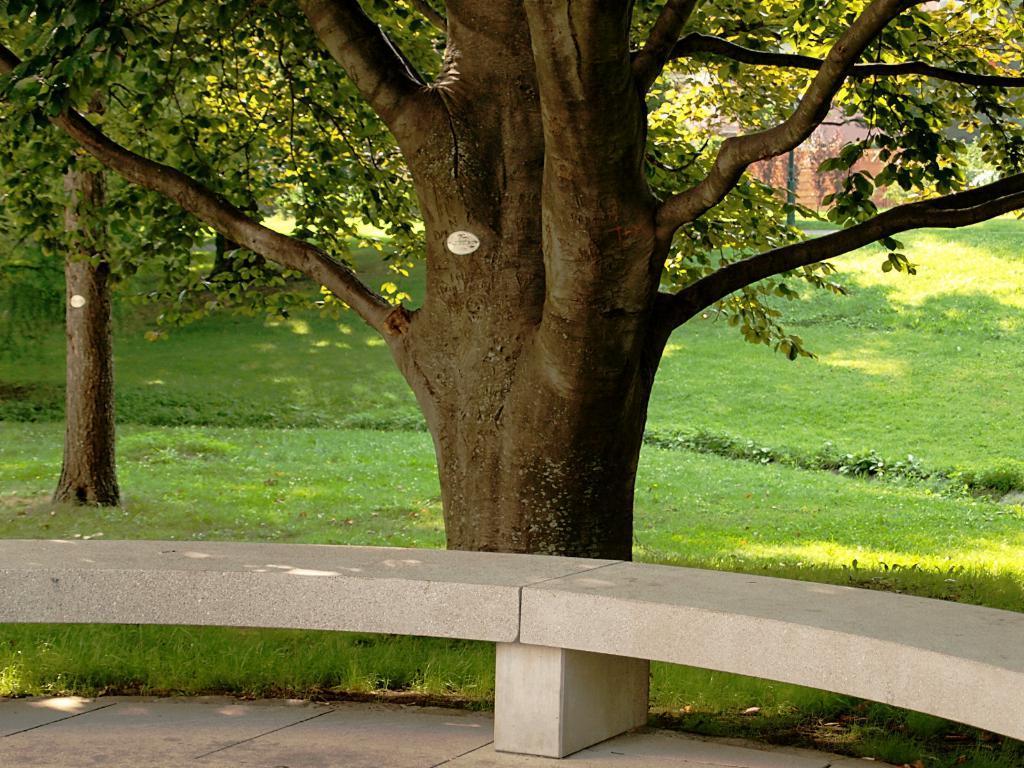Can you describe this image briefly? In the image there are trees on the grassland with a bench in front of it. 